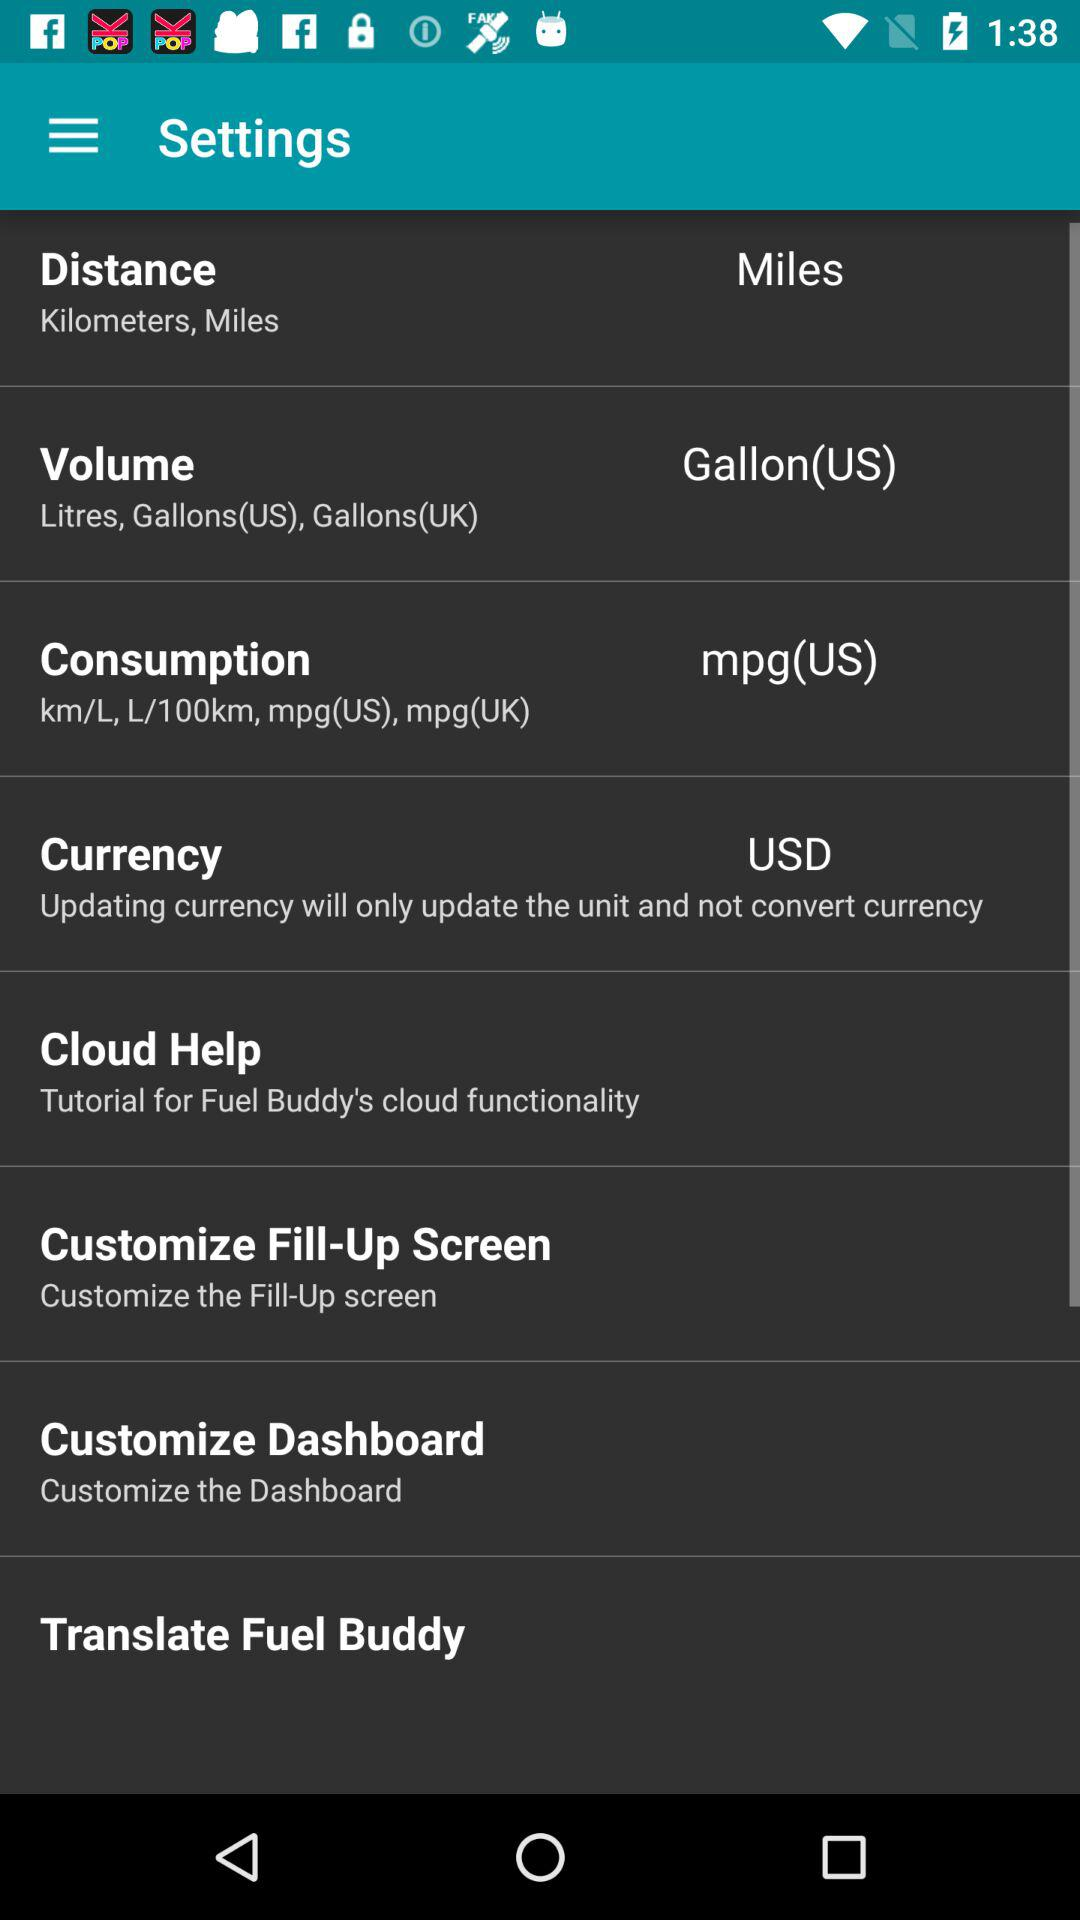Which currency unit was selected? The selected currency unit was USD. 